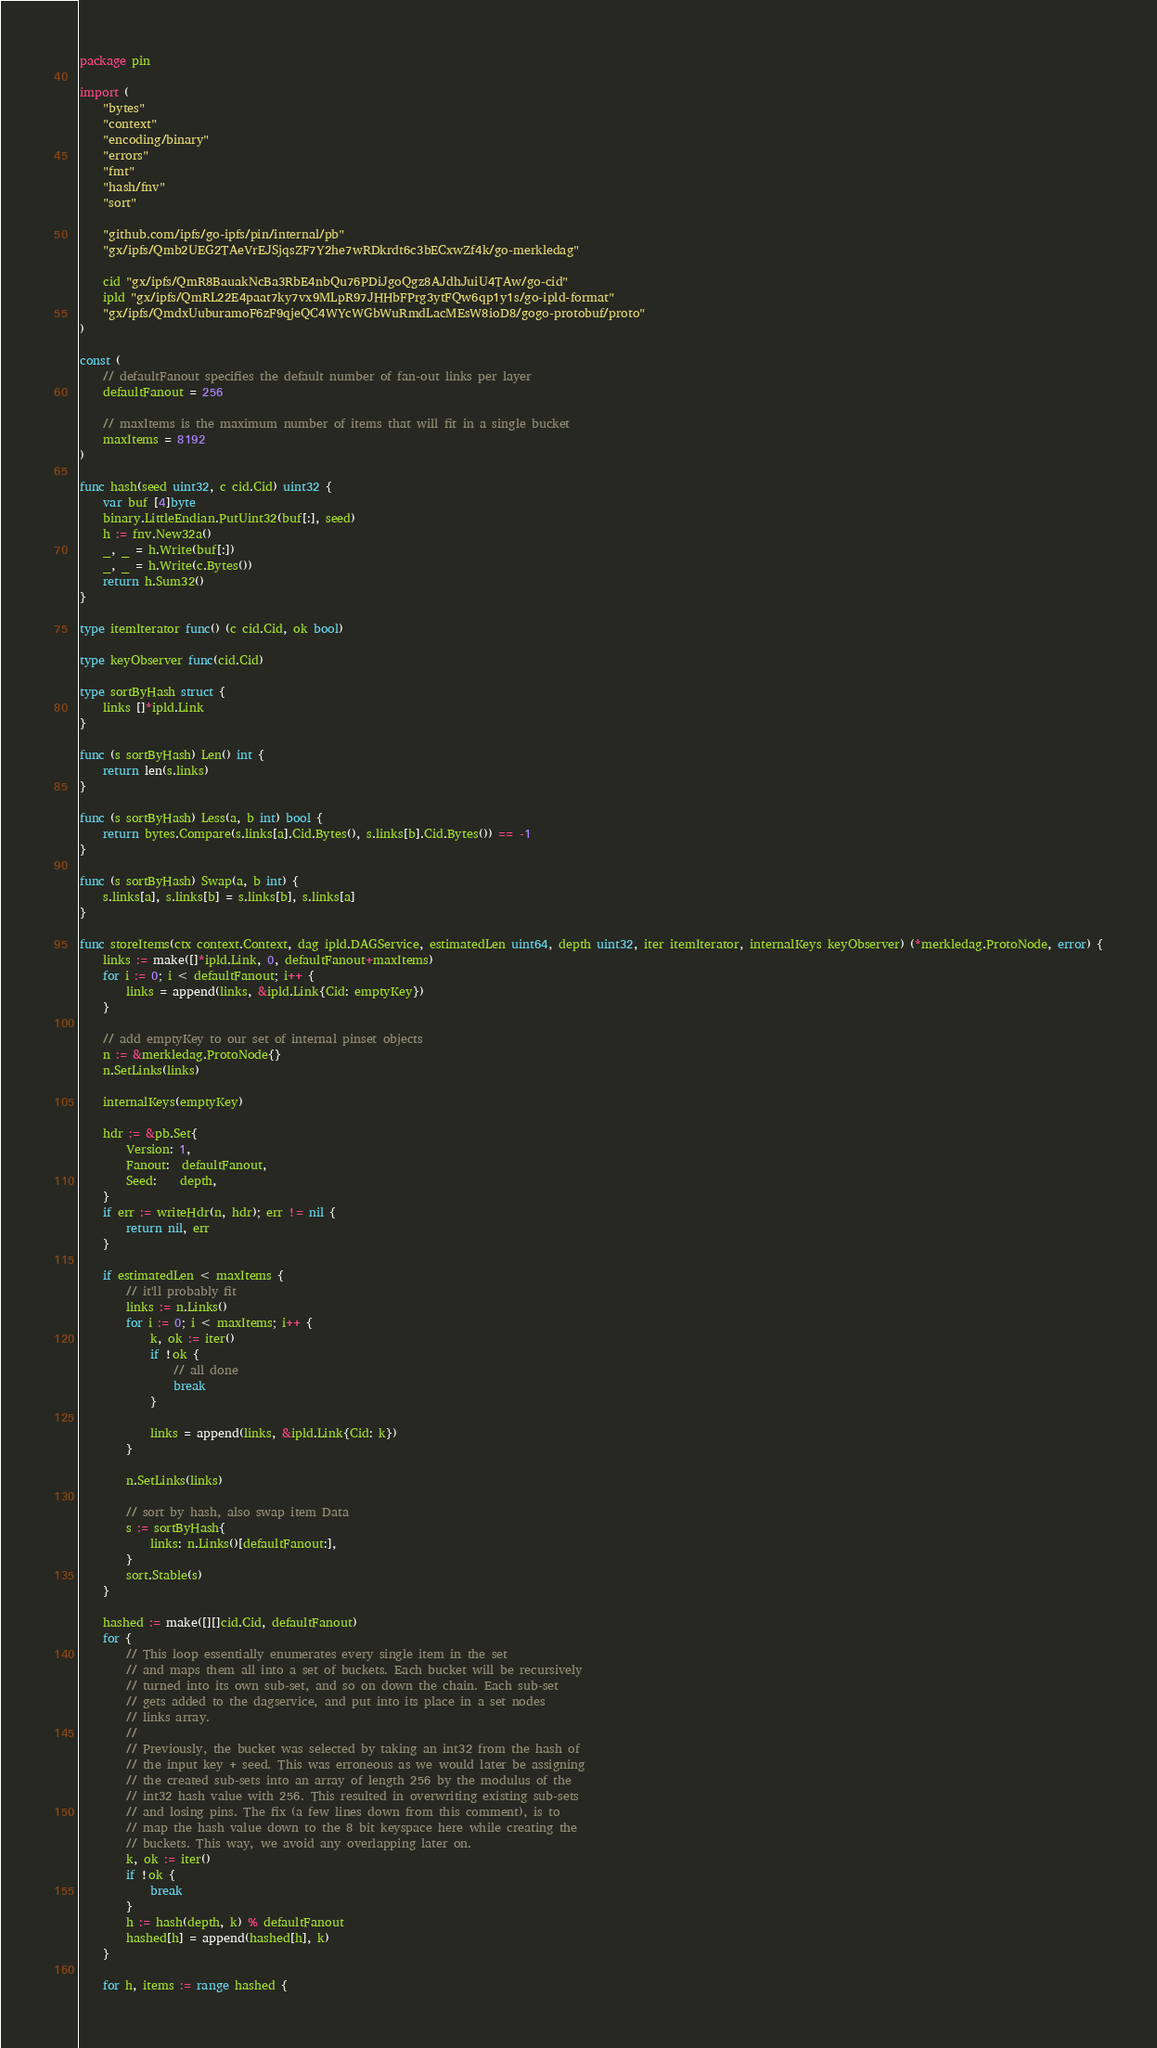Convert code to text. <code><loc_0><loc_0><loc_500><loc_500><_Go_>package pin

import (
	"bytes"
	"context"
	"encoding/binary"
	"errors"
	"fmt"
	"hash/fnv"
	"sort"

	"github.com/ipfs/go-ipfs/pin/internal/pb"
	"gx/ipfs/Qmb2UEG2TAeVrEJSjqsZF7Y2he7wRDkrdt6c3bECxwZf4k/go-merkledag"

	cid "gx/ipfs/QmR8BauakNcBa3RbE4nbQu76PDiJgoQgz8AJdhJuiU4TAw/go-cid"
	ipld "gx/ipfs/QmRL22E4paat7ky7vx9MLpR97JHHbFPrg3ytFQw6qp1y1s/go-ipld-format"
	"gx/ipfs/QmdxUuburamoF6zF9qjeQC4WYcWGbWuRmdLacMEsW8ioD8/gogo-protobuf/proto"
)

const (
	// defaultFanout specifies the default number of fan-out links per layer
	defaultFanout = 256

	// maxItems is the maximum number of items that will fit in a single bucket
	maxItems = 8192
)

func hash(seed uint32, c cid.Cid) uint32 {
	var buf [4]byte
	binary.LittleEndian.PutUint32(buf[:], seed)
	h := fnv.New32a()
	_, _ = h.Write(buf[:])
	_, _ = h.Write(c.Bytes())
	return h.Sum32()
}

type itemIterator func() (c cid.Cid, ok bool)

type keyObserver func(cid.Cid)

type sortByHash struct {
	links []*ipld.Link
}

func (s sortByHash) Len() int {
	return len(s.links)
}

func (s sortByHash) Less(a, b int) bool {
	return bytes.Compare(s.links[a].Cid.Bytes(), s.links[b].Cid.Bytes()) == -1
}

func (s sortByHash) Swap(a, b int) {
	s.links[a], s.links[b] = s.links[b], s.links[a]
}

func storeItems(ctx context.Context, dag ipld.DAGService, estimatedLen uint64, depth uint32, iter itemIterator, internalKeys keyObserver) (*merkledag.ProtoNode, error) {
	links := make([]*ipld.Link, 0, defaultFanout+maxItems)
	for i := 0; i < defaultFanout; i++ {
		links = append(links, &ipld.Link{Cid: emptyKey})
	}

	// add emptyKey to our set of internal pinset objects
	n := &merkledag.ProtoNode{}
	n.SetLinks(links)

	internalKeys(emptyKey)

	hdr := &pb.Set{
		Version: 1,
		Fanout:  defaultFanout,
		Seed:    depth,
	}
	if err := writeHdr(n, hdr); err != nil {
		return nil, err
	}

	if estimatedLen < maxItems {
		// it'll probably fit
		links := n.Links()
		for i := 0; i < maxItems; i++ {
			k, ok := iter()
			if !ok {
				// all done
				break
			}

			links = append(links, &ipld.Link{Cid: k})
		}

		n.SetLinks(links)

		// sort by hash, also swap item Data
		s := sortByHash{
			links: n.Links()[defaultFanout:],
		}
		sort.Stable(s)
	}

	hashed := make([][]cid.Cid, defaultFanout)
	for {
		// This loop essentially enumerates every single item in the set
		// and maps them all into a set of buckets. Each bucket will be recursively
		// turned into its own sub-set, and so on down the chain. Each sub-set
		// gets added to the dagservice, and put into its place in a set nodes
		// links array.
		//
		// Previously, the bucket was selected by taking an int32 from the hash of
		// the input key + seed. This was erroneous as we would later be assigning
		// the created sub-sets into an array of length 256 by the modulus of the
		// int32 hash value with 256. This resulted in overwriting existing sub-sets
		// and losing pins. The fix (a few lines down from this comment), is to
		// map the hash value down to the 8 bit keyspace here while creating the
		// buckets. This way, we avoid any overlapping later on.
		k, ok := iter()
		if !ok {
			break
		}
		h := hash(depth, k) % defaultFanout
		hashed[h] = append(hashed[h], k)
	}

	for h, items := range hashed {</code> 